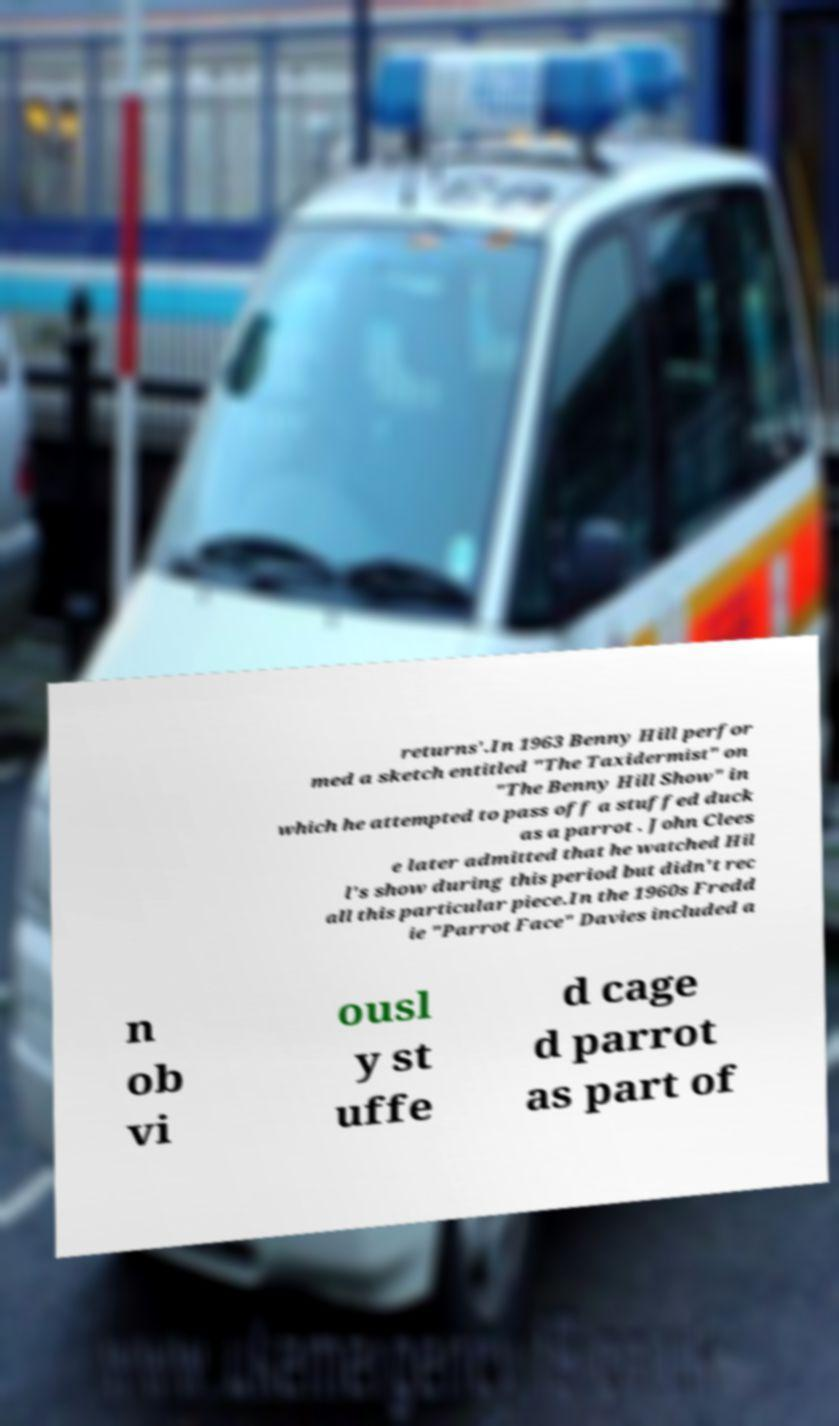Please identify and transcribe the text found in this image. returns'.In 1963 Benny Hill perfor med a sketch entitled "The Taxidermist" on "The Benny Hill Show" in which he attempted to pass off a stuffed duck as a parrot . John Clees e later admitted that he watched Hil l's show during this period but didn't rec all this particular piece.In the 1960s Fredd ie "Parrot Face" Davies included a n ob vi ousl y st uffe d cage d parrot as part of 